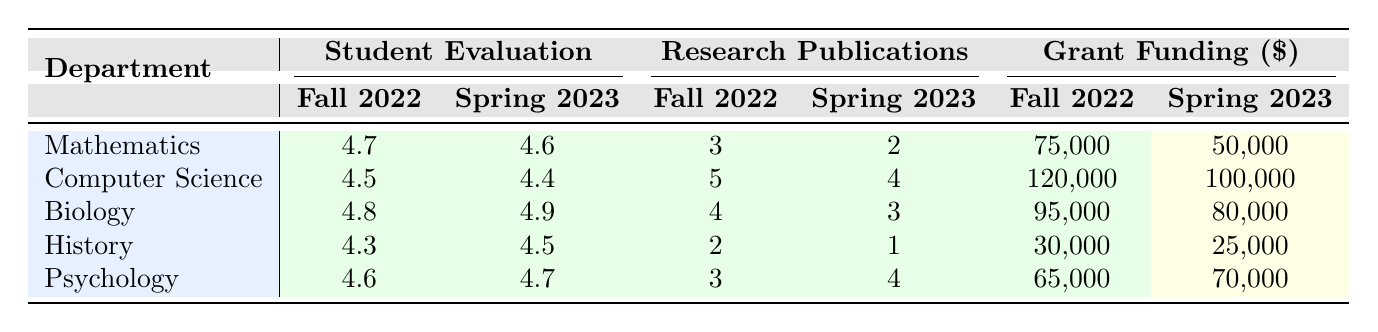What is the student evaluation score for the Biology department in Spring 2023? In the Spring 2023 row for the Biology department, the student evaluation score listed is 4.9.
Answer: 4.9 Which department had the highest grant funding secured in Fall 2022? The Computer Science department had the highest grant funding secured in Fall 2022, with a total of 120,000.
Answer: Computer Science What is the average student evaluation score for the Psychology department across both semesters? The scores for Psychology are 4.6 in Fall 2022 and 4.7 in Spring 2023. The average is calculated as (4.6 + 4.7) / 2 = 4.65.
Answer: 4.65 Did the History department secure more grant funding in Spring 2023 compared to Fall 2022? In Fall 2022, the History department secured 30,000, while in Spring 2023, they secured 25,000. Therefore, they secured less in Spring 2023 compared to Fall 2022.
Answer: No Which department had the greatest decrease in research publications from Fall 2022 to Spring 2023? Examining the research publications: Mathematics had 3 in Fall 2022 and 2 in Spring 2023 (-1), Computer Science had 5 and 4 (-1), Biology had 4 and 3 (-1), History had 2 and 1 (-1), and Psychology had 3 and 4 (+1). The greatest decrease is from Mathematics, Computer Science, Biology, and History, each with a decrease of 1, but no one stands out as significantly more than the others.
Answer: No department had a greater decrease What is the total number of courses taught by faculty in the Computer Science department across both semesters? In Fall 2022, Computer Science faculty taught 3 courses, and in Spring 2023, they taught 2 courses. Adding them together gives 3 + 2 = 5 courses.
Answer: 5 Which semester had a higher average class size for the Psychology department? In Fall 2022, the average class size was 38, and in Spring 2023, it was 42. Since 42 is greater than 38, Spring 2023 had a higher average class size.
Answer: Spring 2023 For which faculty member was the grant funding secured the highest in Fall 2022? The faculty member with the highest grant funding secured in Fall 2022 was Prof. Michael Chen from the Computer Science department, with a total of 120,000 secured.
Answer: Prof. Michael Chen How many total research publications were made by the faculty in the Biology department across both semesters? Faculty in the Biology department had 4 research publications in Fall 2022 and 3 in Spring 2023. Adding these gives 4 + 3 = 7 publications.
Answer: 7 